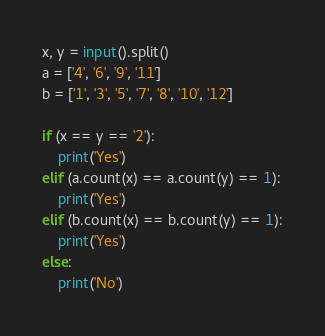<code> <loc_0><loc_0><loc_500><loc_500><_Python_>x, y = input().split()
a = ['4', '6', '9', '11']
b = ['1', '3', '5', '7', '8', '10', '12']

if (x == y == '2'):
	print('Yes')
elif (a.count(x) == a.count(y) == 1):
	print('Yes')
elif (b.count(x) == b.count(y) == 1):
	print('Yes')
else:
	print('No')</code> 